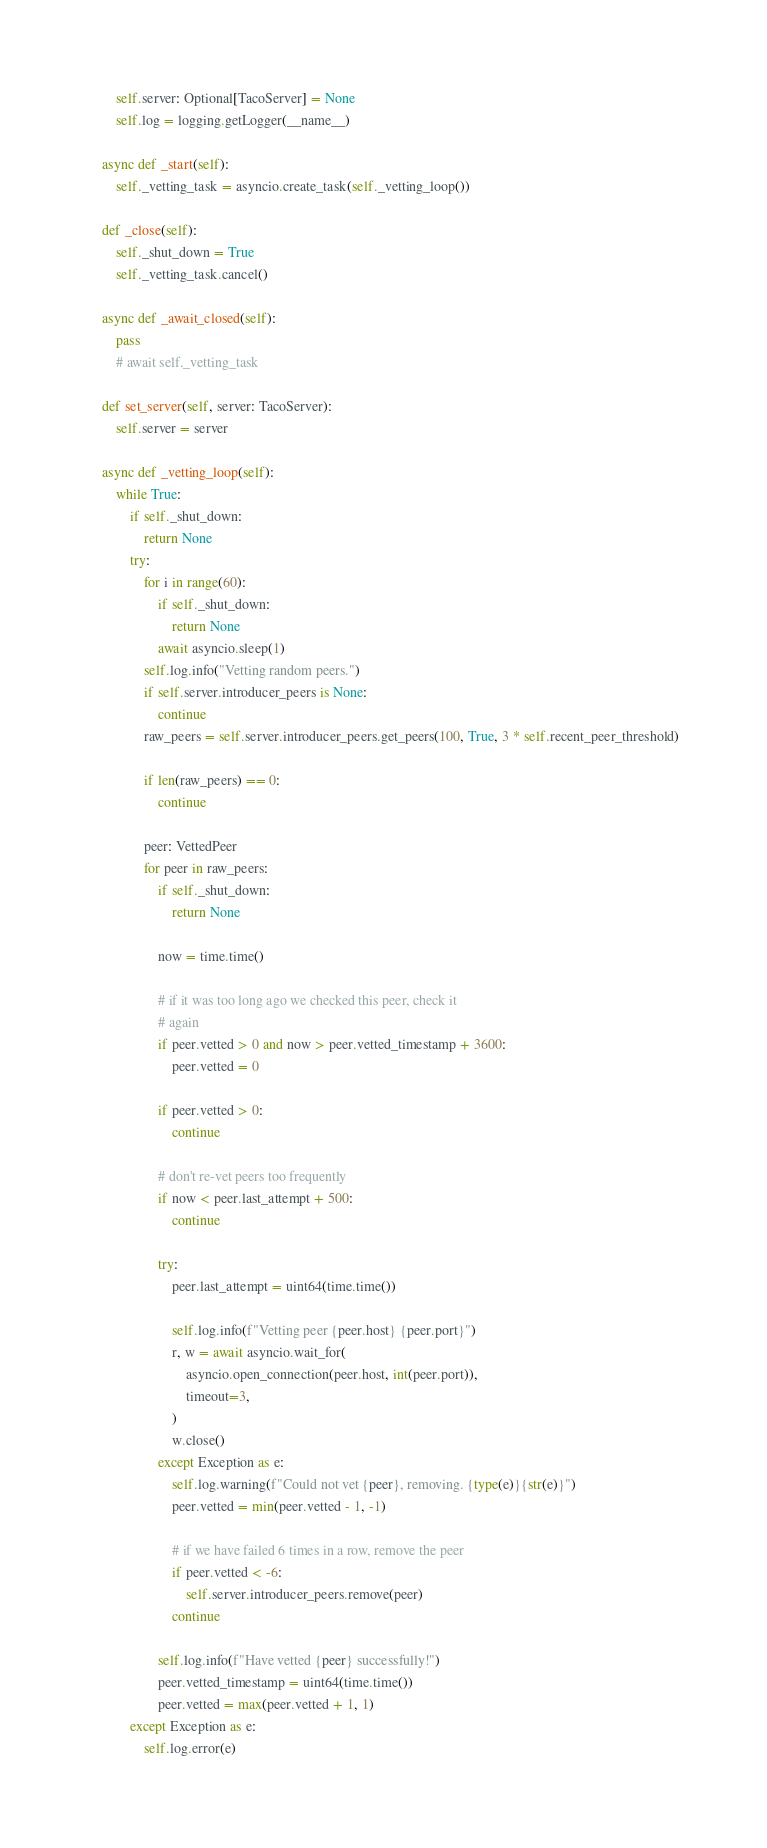Convert code to text. <code><loc_0><loc_0><loc_500><loc_500><_Python_>        self.server: Optional[TacoServer] = None
        self.log = logging.getLogger(__name__)

    async def _start(self):
        self._vetting_task = asyncio.create_task(self._vetting_loop())

    def _close(self):
        self._shut_down = True
        self._vetting_task.cancel()

    async def _await_closed(self):
        pass
        # await self._vetting_task

    def set_server(self, server: TacoServer):
        self.server = server

    async def _vetting_loop(self):
        while True:
            if self._shut_down:
                return None
            try:
                for i in range(60):
                    if self._shut_down:
                        return None
                    await asyncio.sleep(1)
                self.log.info("Vetting random peers.")
                if self.server.introducer_peers is None:
                    continue
                raw_peers = self.server.introducer_peers.get_peers(100, True, 3 * self.recent_peer_threshold)

                if len(raw_peers) == 0:
                    continue

                peer: VettedPeer
                for peer in raw_peers:
                    if self._shut_down:
                        return None

                    now = time.time()

                    # if it was too long ago we checked this peer, check it
                    # again
                    if peer.vetted > 0 and now > peer.vetted_timestamp + 3600:
                        peer.vetted = 0

                    if peer.vetted > 0:
                        continue

                    # don't re-vet peers too frequently
                    if now < peer.last_attempt + 500:
                        continue

                    try:
                        peer.last_attempt = uint64(time.time())

                        self.log.info(f"Vetting peer {peer.host} {peer.port}")
                        r, w = await asyncio.wait_for(
                            asyncio.open_connection(peer.host, int(peer.port)),
                            timeout=3,
                        )
                        w.close()
                    except Exception as e:
                        self.log.warning(f"Could not vet {peer}, removing. {type(e)}{str(e)}")
                        peer.vetted = min(peer.vetted - 1, -1)

                        # if we have failed 6 times in a row, remove the peer
                        if peer.vetted < -6:
                            self.server.introducer_peers.remove(peer)
                        continue

                    self.log.info(f"Have vetted {peer} successfully!")
                    peer.vetted_timestamp = uint64(time.time())
                    peer.vetted = max(peer.vetted + 1, 1)
            except Exception as e:
                self.log.error(e)
</code> 